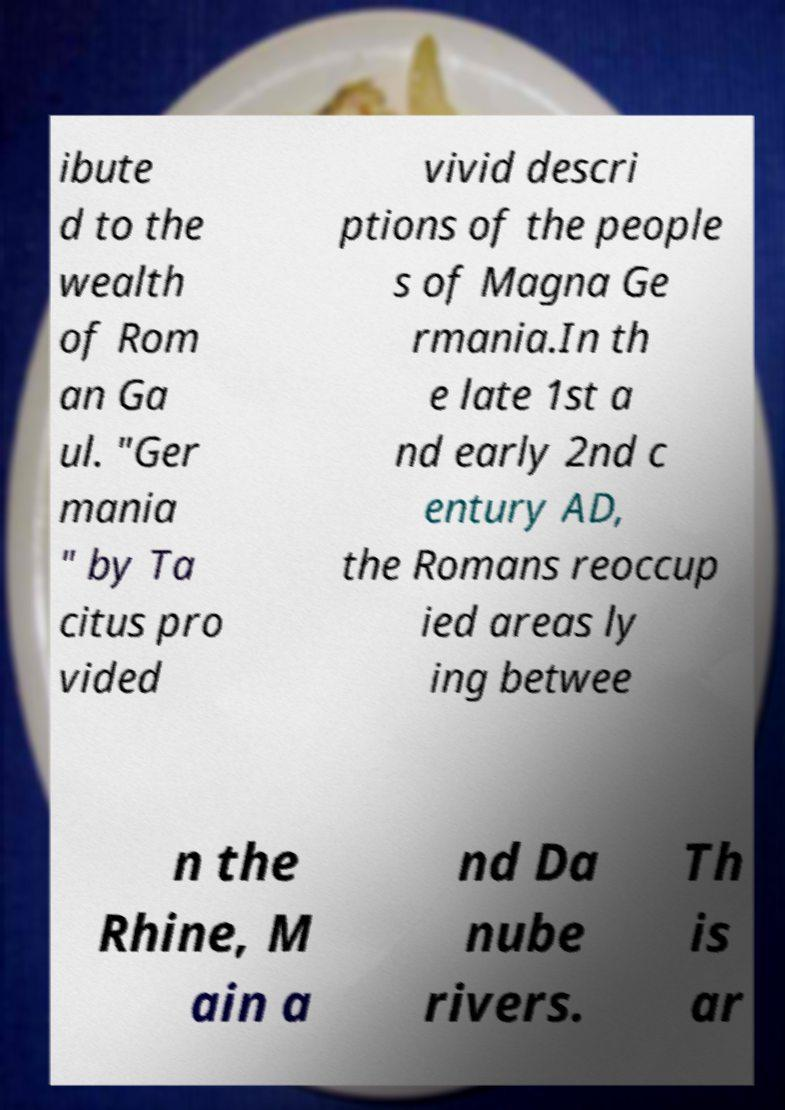What messages or text are displayed in this image? I need them in a readable, typed format. ibute d to the wealth of Rom an Ga ul. "Ger mania " by Ta citus pro vided vivid descri ptions of the people s of Magna Ge rmania.In th e late 1st a nd early 2nd c entury AD, the Romans reoccup ied areas ly ing betwee n the Rhine, M ain a nd Da nube rivers. Th is ar 